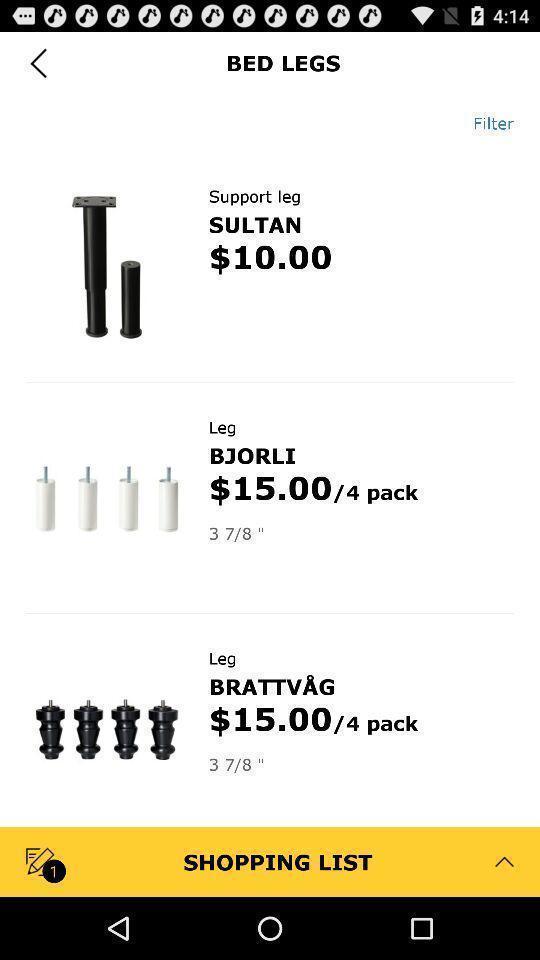Tell me what you see in this picture. Screen showing page of an shopping application. 